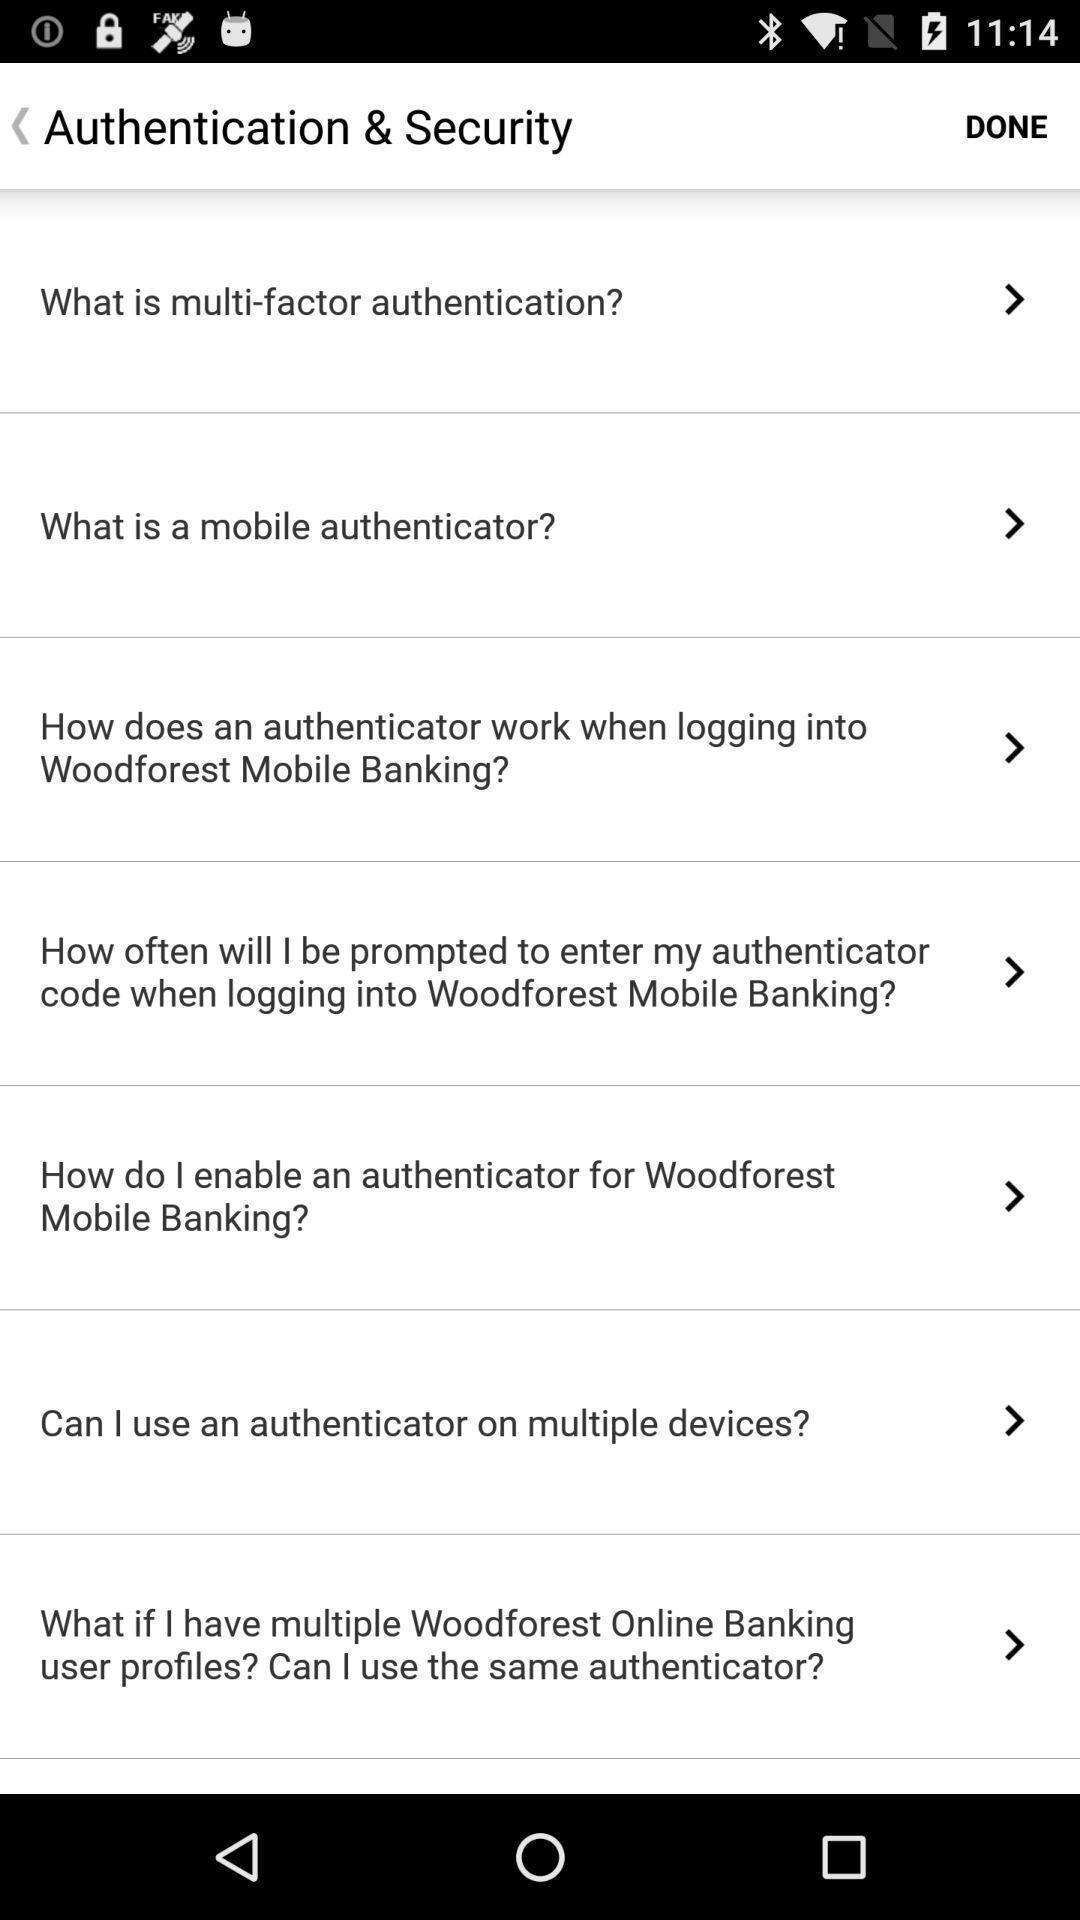Summarize the main components in this picture. Security page with many other options. 